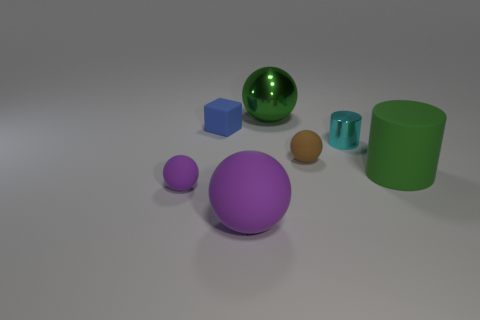What size is the cylinder that is the same color as the metallic ball?
Your answer should be very brief. Large. What number of other objects are there of the same size as the blue matte thing?
Your response must be concise. 3. Does the shiny ball have the same color as the small shiny thing?
Your answer should be very brief. No. Is the shape of the big green object behind the rubber cylinder the same as  the large purple rubber object?
Provide a short and direct response. Yes. How many balls are both behind the tiny blue rubber cube and in front of the brown matte sphere?
Make the answer very short. 0. What is the tiny purple object made of?
Your answer should be very brief. Rubber. Is there anything else that is the same color as the small cylinder?
Provide a short and direct response. No. Does the tiny purple ball have the same material as the brown sphere?
Your answer should be very brief. Yes. How many brown matte balls are to the right of the brown ball that is right of the thing that is left of the cube?
Offer a very short reply. 0. What number of small rubber cubes are there?
Make the answer very short. 1. 